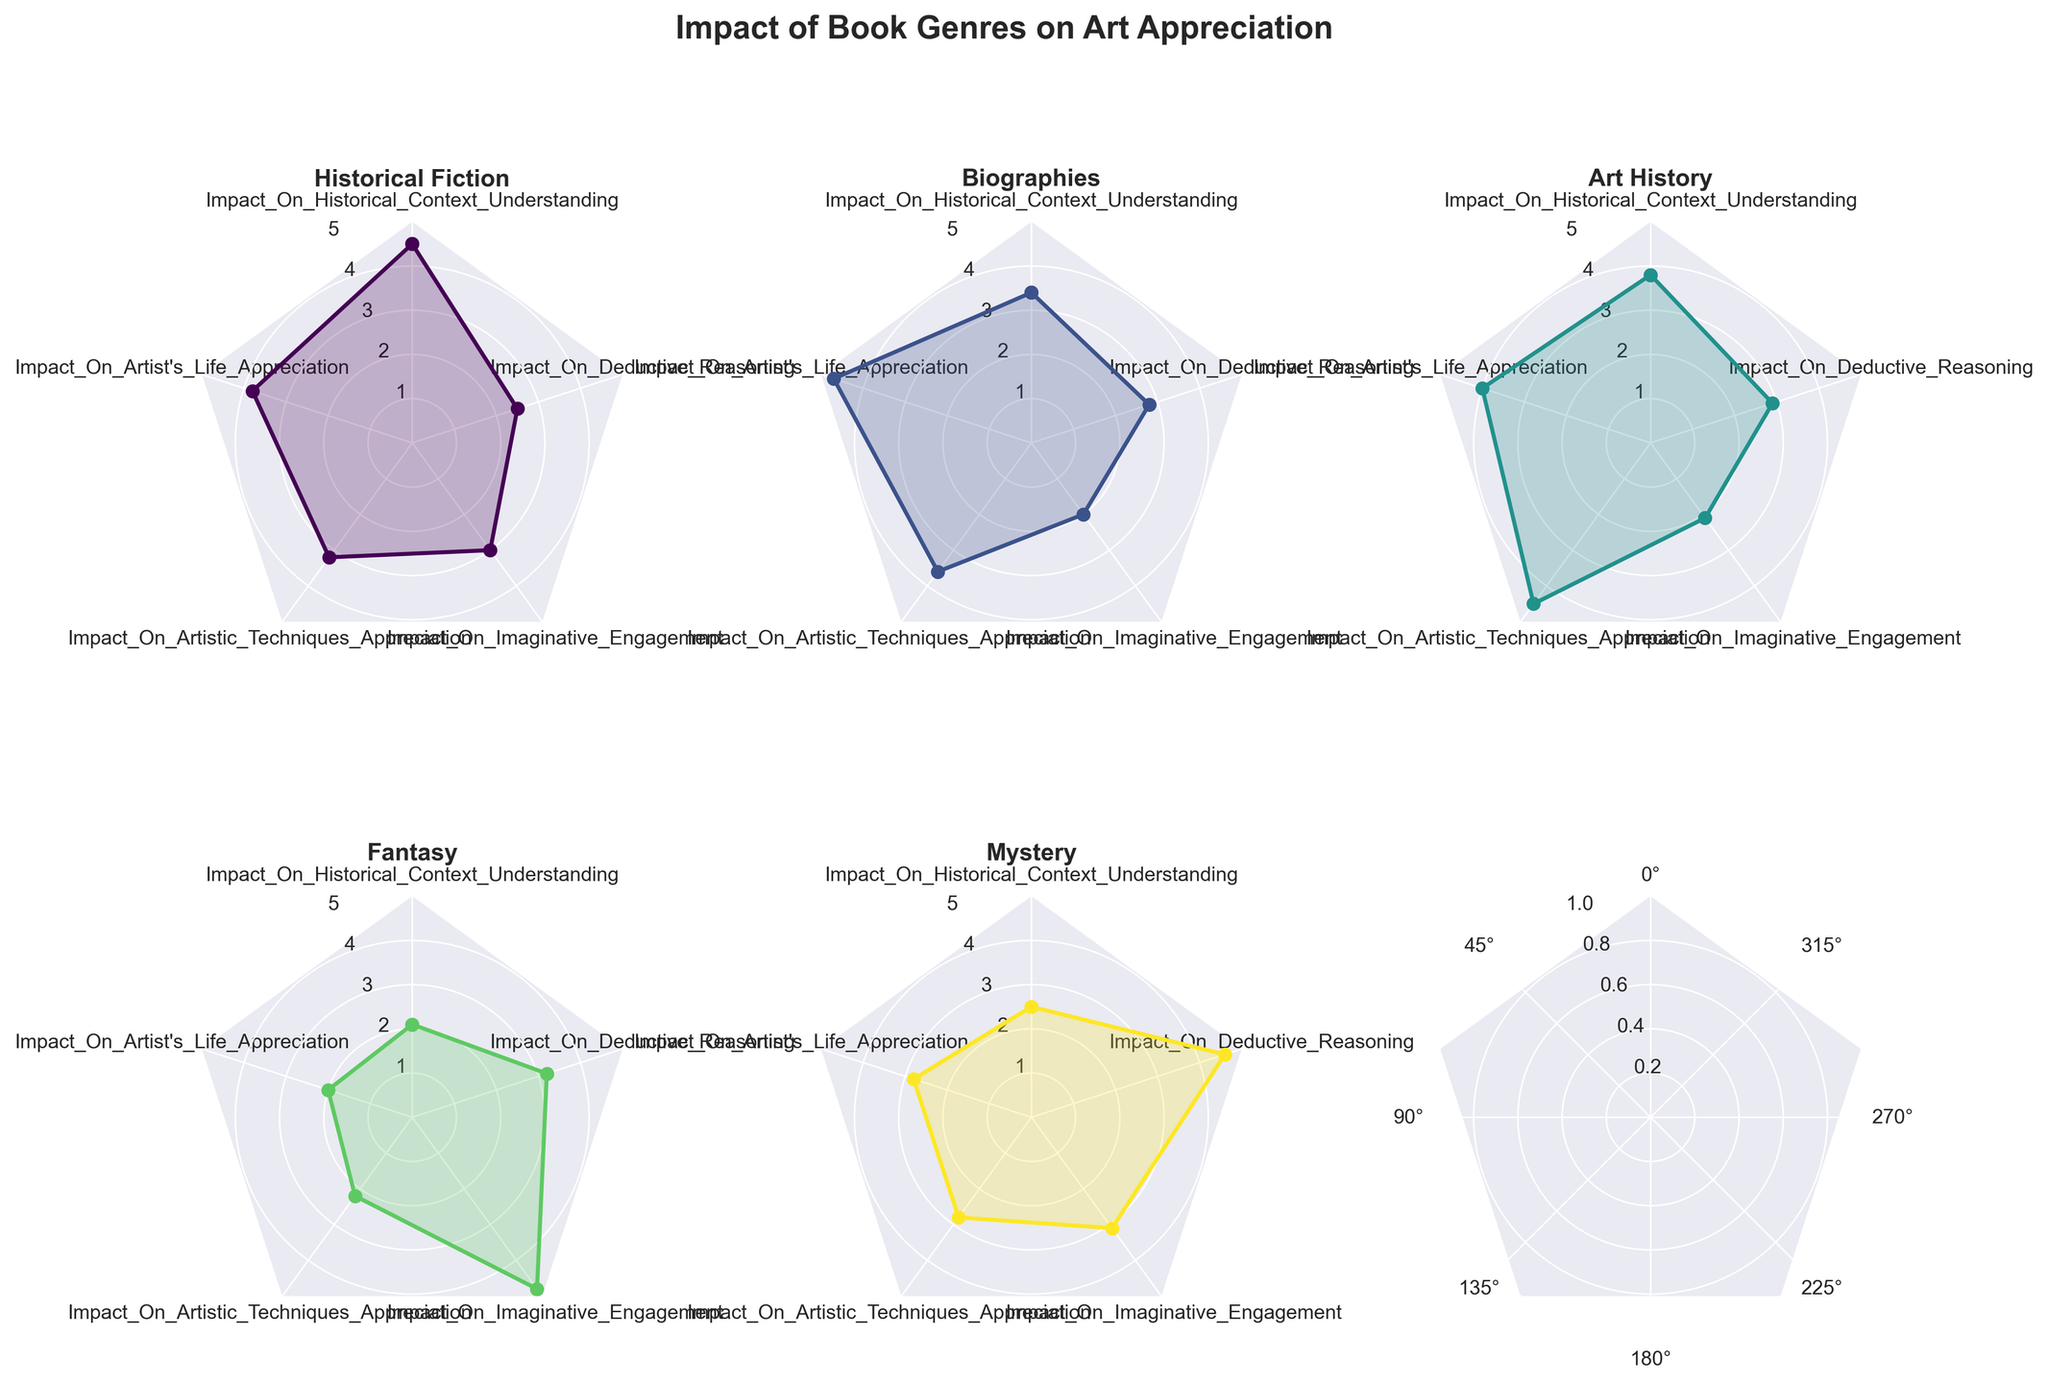How many book genres are analyzed in the figure? The figure has subplots for each book genre. Counting the subplots will give the total number of book genres analyzed in the figure. There are five subplots.
Answer: Five What is the title of the figure? The title is usually placed at the top of the figure. "Impact of Book Genres on Art Appreciation" is the title written at the top.
Answer: Impact of Book Genres on Art Appreciation Which book genre has the highest impact on imaginative engagement? Looking at each subplot under the "Imaginative Engagement" variable, locate the peak point. The genre with the highest peak under this variable is Fantasy.
Answer: Fantasy Comparing "Historical Fiction" and "Biographies," which book genre has a greater impact on appreciating artistic techniques? Find the "Artistic Techniques Appreciation" values from the subplots for Historical Fiction and Biographies. Historical Fiction has 3.2 and Biographies have 3.6. Since 3.6 is greater than 3.2, Biographies have a greater impact.
Answer: Biographies What is the average impact of Art History on the five art appreciation categories? Sum the values for "Impact of Art History" across all five variables and divide by the number of variables: (3.8 + 4.0 + 4.5 + 2.1 + 2.9)/5 = 17.3/5 = 3.46.
Answer: 3.46 Does any book genre exhibit a balanced influence across all five categories? A balanced influence would mean all five radar points are roughly equal in length. Historical Fiction and Art History notably have more balanced distributions, but Art History is closer to equality. Determine closeness by less drastic deviations in all five variables.
Answer: Art History Which genre contributes the least to deductive reasoning? Compare the "Deductive Reasoning" scores in each subplot, observing the lowest points. Historical Fiction has the lowest value with 2.5.
Answer: Historical Fiction Is there any genre that has its lowest impact on appreciating the artist's life? Look at the "Artist's Life Appreciation" variable across all subplots and find the minimal values. Fantasy has the lowest impact with a value of 2.0.
Answer: Fantasy Which genres have greater than 4 impact values on at least one category? Observe subplots and identify genres with at least one peak equal to or surpassing 4 on any category. Historical Fiction (4.5 on Historical Context), Biographies (4.7 on Artist's Life), Art History (4.5 on Artistic Techniques), Fantasy (4.8 on Imaginative Engagement), and Mystery (4.6 on Deductive Reasoning) qualify.
Answer: Historical Fiction, Biographies, Art History, Fantasy, Mystery Considering the genre "Mystery," what is the range of its impact values? Identify the maximum and minimum values among its five categories and find the range: Max=4.6, Min=2.5, Range = 4.6 - 2.5 = 2.1.
Answer: 2.1 